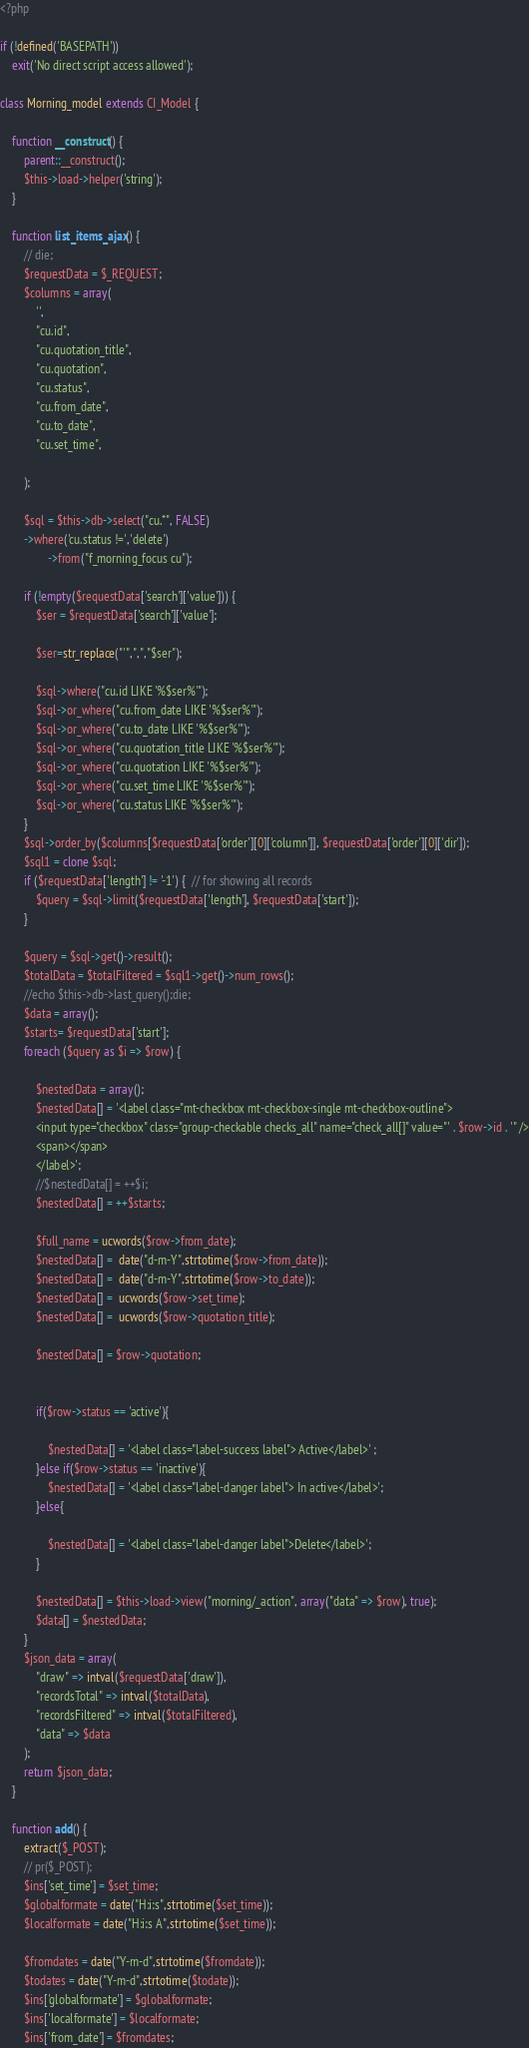<code> <loc_0><loc_0><loc_500><loc_500><_PHP_><?php

if (!defined('BASEPATH'))
    exit('No direct script access allowed');

class Morning_model extends CI_Model {

    function __construct() {
        parent::__construct();
        $this->load->helper('string');
    }

    function list_items_ajax() {
        // die;
        $requestData = $_REQUEST;
        $columns = array(
            '',
            "cu.id",
            "cu.quotation_title",
            "cu.quotation",
            "cu.status",
            "cu.from_date",
            "cu.to_date",
            "cu.set_time",
            
        );

        $sql = $this->db->select("cu.*", FALSE)
        ->where('cu.status !=','delete')
                ->from("f_morning_focus cu");

        if (!empty($requestData['search']['value'])) {
            $ser = $requestData['search']['value'];

            $ser=str_replace("'",",","$ser");
          
            $sql->where("cu.id LIKE '%$ser%'");
            $sql->or_where("cu.from_date LIKE '%$ser%'");
            $sql->or_where("cu.to_date LIKE '%$ser%'");
            $sql->or_where("cu.quotation_title LIKE '%$ser%'");
            $sql->or_where("cu.quotation LIKE '%$ser%'");
            $sql->or_where("cu.set_time LIKE '%$ser%'");
            $sql->or_where("cu.status LIKE '%$ser%'");
        }
        $sql->order_by($columns[$requestData['order'][0]['column']], $requestData['order'][0]['dir']);
        $sql1 = clone $sql;
        if ($requestData['length'] != '-1') {  // for showing all records
            $query = $sql->limit($requestData['length'], $requestData['start']);
        }

        $query = $sql->get()->result();
        $totalData = $totalFiltered = $sql1->get()->num_rows();
        //echo $this->db->last_query();die;
        $data = array();
        $starts= $requestData['start'];
        foreach ($query as $i => $row) {
        
            $nestedData = array();
            $nestedData[] = '<label class="mt-checkbox mt-checkbox-single mt-checkbox-outline">
            <input type="checkbox" class="group-checkable checks_all" name="check_all[]" value="' . $row->id . '" />
            <span></span>
            </label>';
            //$nestedData[] = ++$i;
            $nestedData[] = ++$starts;
            
            $full_name = ucwords($row->from_date);
            $nestedData[] =  date("d-m-Y",strtotime($row->from_date));
            $nestedData[] =  date("d-m-Y",strtotime($row->to_date));
            $nestedData[] =  ucwords($row->set_time);
            $nestedData[] =  ucwords($row->quotation_title);

            $nestedData[] = $row->quotation;


            if($row->status == 'active'){

                $nestedData[] = '<label class="label-success label"> Active</label>' ;
            }else if($row->status == 'inactive'){
                $nestedData[] = '<label class="label-danger label"> In active</label>';
            }else{
                
                $nestedData[] = '<label class="label-danger label">Delete</label>';
            }
           
            $nestedData[] = $this->load->view("morning/_action", array("data" => $row), true);
            $data[] = $nestedData;
        }
        $json_data = array(
            "draw" => intval($requestData['draw']),
            "recordsTotal" => intval($totalData),
            "recordsFiltered" => intval($totalFiltered),
            "data" => $data
        );
        return $json_data;
    }

    function add() {
        extract($_POST);
        // pr($_POST); 
        $ins['set_time'] = $set_time;
        $globalformate = date("H:i:s",strtotime($set_time));
        $localformate = date("H:i:s A",strtotime($set_time));
        
        $fromdates = date("Y-m-d",strtotime($fromdate));
        $todates = date("Y-m-d",strtotime($todate));
        $ins['globalformate'] = $globalformate;
        $ins['localformate'] = $localformate;
        $ins['from_date'] = $fromdates;</code> 